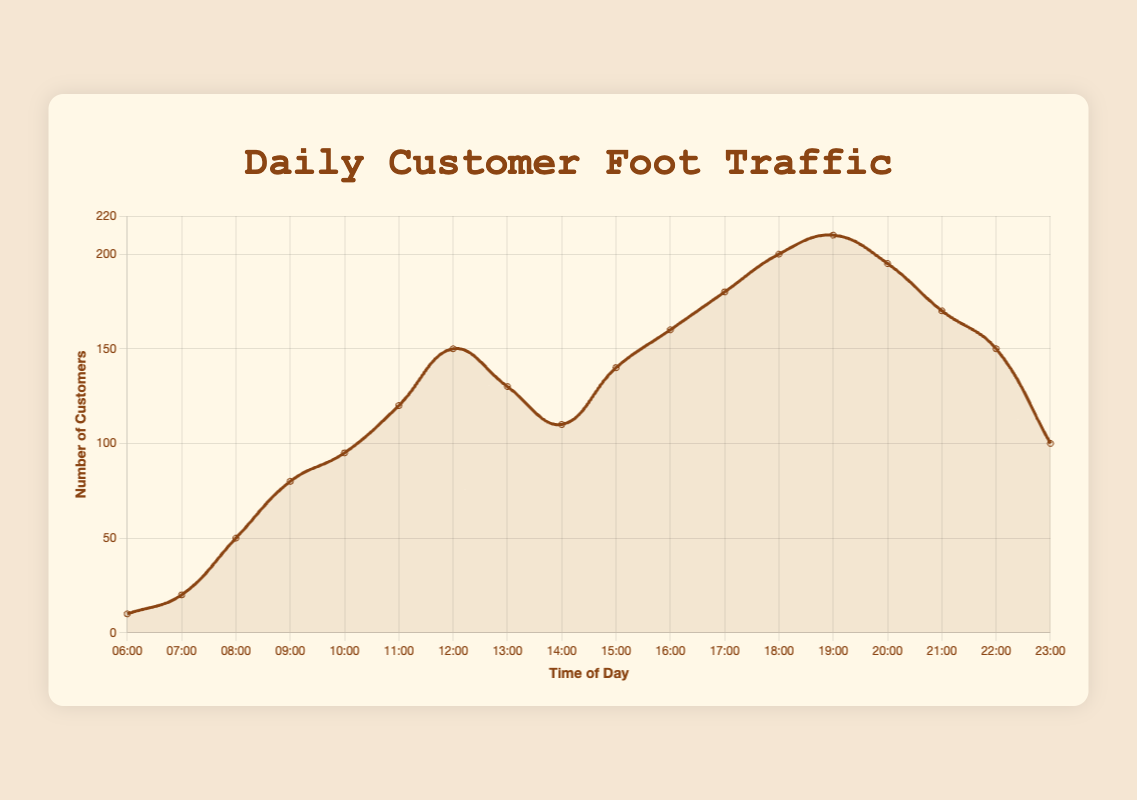What time does customer foot traffic start increasing significantly in the morning? The figure shows the customer foot traffic starting to increase significantly between 06:00 and 08:00, and it continues to rise until 10:00.
Answer: 08:00 At what time does customer foot traffic reach its highest point in the day? According to the figure, the customer foot traffic reaches its peak at 19:00.
Answer: 19:00 How does the evening peak period compare to the morning peak period in terms of customer foot traffic? From the figure, during the evening peak (17:00 - 20:00), foot traffic ranges from 180 to 210. In the morning peak (08:00 - 10:00), it ranges from 50 to 95. Therefore, evening peak traffic is higher than morning peak traffic.
Answer: Evening peak is higher What is the total customer foot traffic during the peak hours throughout the day? To find the total foot traffic during peak hours, sum the values from 08:00 to 10:00 (50 + 80 + 95 = 225), 12:00 to 13:00 (150 + 130 = 280), and 17:00 to 20:00 (180 + 200 + 210 + 195 = 785). Adding these gives 225 + 280 + 785 = 1290.
Answer: 1290 During which peak period is customer foot traffic the highest? By comparing the foot traffic values during the morning, afternoon, and evening peak periods from the figure, the evening peak period (17:00 - 20:00) has the highest individual value of 210 at 19:00.
Answer: Evening peak What's the average customer foot traffic in the afternoon peak period? For the afternoon peak period, calculate the average of the foot traffic at 12:00 and 13:00. The values are 150 and 130. The average is (150 + 130) / 2 = 140.
Answer: 140 How does customer foot traffic at 15:00 compare to 21:00? From the figure, the foot traffic at 15:00 is 140, while at 21:00 it is 170. Therefore, foot traffic at 21:00 is higher than at 15:00.
Answer: 21:00 is higher Which time period between 14:00 and 18:00 shows the steepest increase in customer foot traffic? Comparing the increase in foot traffic between 14:00 and 18:00, 15:00 to 16:00 increases from 140 to 160, and 16:00 to 17:00 increases from 160 to 180, both are significant, but 18:00 shows the steepest increase to 200.
Answer: 17:00 to 18:00 What's the difference in customer foot traffic between the start and end of the evening peak period? Evaluating the difference from 17:00 (180 customers) to 20:00 (195 customers), the traffic increases by 195 - 180 = 15.
Answer: 15 